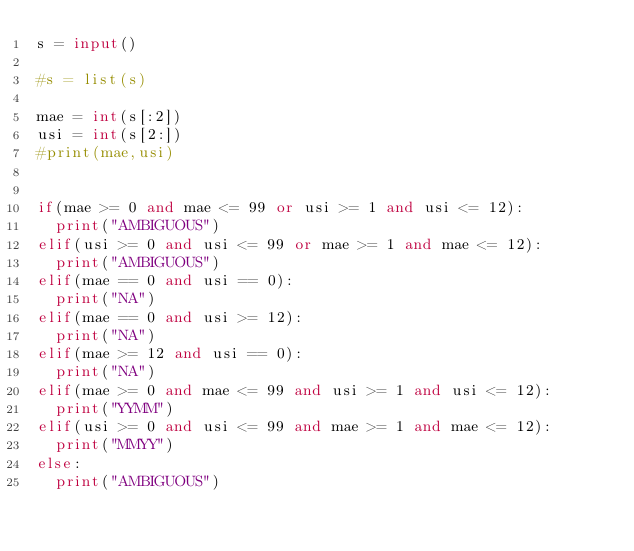<code> <loc_0><loc_0><loc_500><loc_500><_Python_>s = input()

#s = list(s)

mae = int(s[:2])
usi = int(s[2:])
#print(mae,usi)


if(mae >= 0 and mae <= 99 or usi >= 1 and usi <= 12):
  print("AMBIGUOUS")
elif(usi >= 0 and usi <= 99 or mae >= 1 and mae <= 12):
  print("AMBIGUOUS")
elif(mae == 0 and usi == 0):
  print("NA")
elif(mae == 0 and usi >= 12):
  print("NA")
elif(mae >= 12 and usi == 0):
  print("NA")
elif(mae >= 0 and mae <= 99 and usi >= 1 and usi <= 12):
  print("YYMM")
elif(usi >= 0 and usi <= 99 and mae >= 1 and mae <= 12):
  print("MMYY")
else:
  print("AMBIGUOUS")</code> 